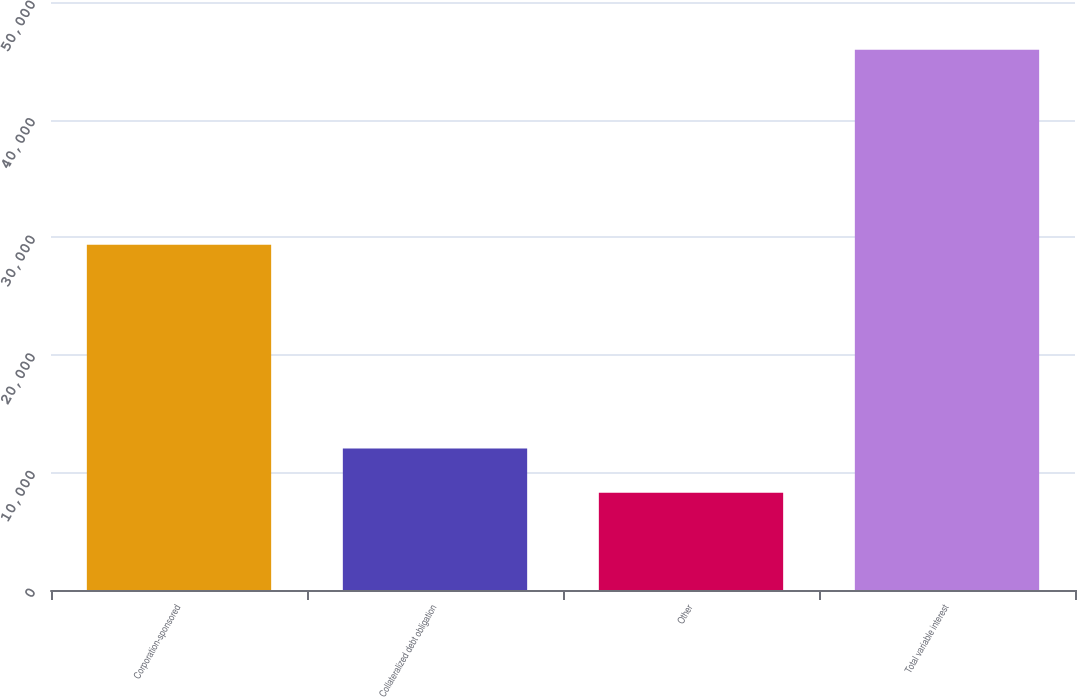Convert chart. <chart><loc_0><loc_0><loc_500><loc_500><bar_chart><fcel>Corporation-sponsored<fcel>Collateralized debt obligation<fcel>Other<fcel>Total variable interest<nl><fcel>29363<fcel>12028.7<fcel>8260<fcel>45947<nl></chart> 